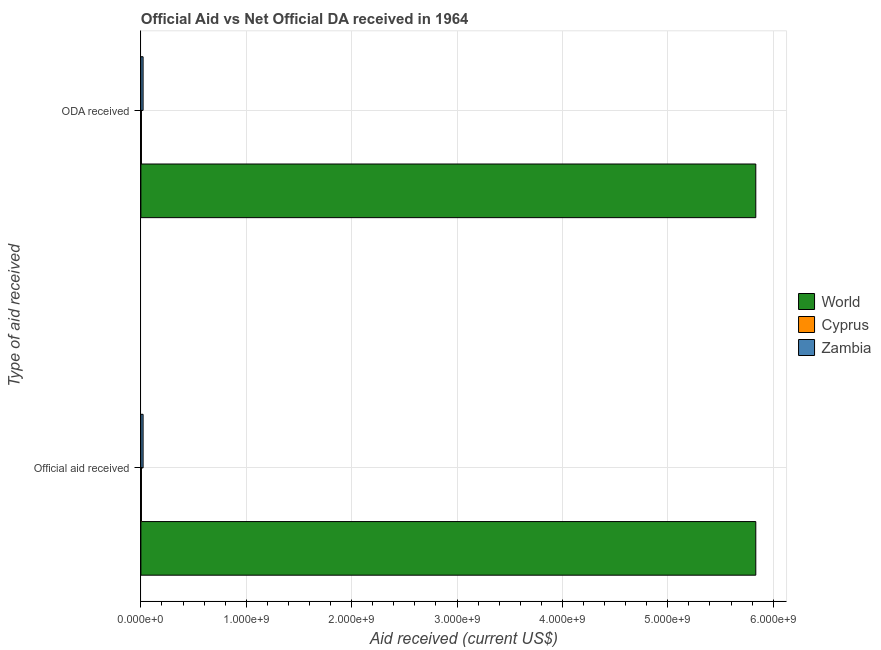How many different coloured bars are there?
Make the answer very short. 3. Are the number of bars per tick equal to the number of legend labels?
Keep it short and to the point. Yes. How many bars are there on the 1st tick from the top?
Your answer should be compact. 3. How many bars are there on the 1st tick from the bottom?
Provide a succinct answer. 3. What is the label of the 1st group of bars from the top?
Ensure brevity in your answer.  ODA received. What is the official aid received in Cyprus?
Keep it short and to the point. 5.24e+06. Across all countries, what is the maximum oda received?
Your answer should be very brief. 5.84e+09. Across all countries, what is the minimum official aid received?
Your response must be concise. 5.24e+06. In which country was the oda received maximum?
Ensure brevity in your answer.  World. In which country was the oda received minimum?
Offer a very short reply. Cyprus. What is the total oda received in the graph?
Offer a terse response. 5.86e+09. What is the difference between the oda received in Zambia and that in Cyprus?
Offer a very short reply. 1.58e+07. What is the difference between the official aid received in Zambia and the oda received in World?
Keep it short and to the point. -5.81e+09. What is the average oda received per country?
Your answer should be very brief. 1.95e+09. What is the difference between the official aid received and oda received in Cyprus?
Your response must be concise. 0. In how many countries, is the official aid received greater than 3800000000 US$?
Offer a very short reply. 1. What is the ratio of the official aid received in Cyprus to that in Zambia?
Offer a very short reply. 0.25. In how many countries, is the oda received greater than the average oda received taken over all countries?
Provide a short and direct response. 1. What does the 3rd bar from the top in ODA received represents?
Make the answer very short. World. What does the 3rd bar from the bottom in ODA received represents?
Offer a very short reply. Zambia. How many bars are there?
Your answer should be very brief. 6. Does the graph contain any zero values?
Give a very brief answer. No. Where does the legend appear in the graph?
Offer a terse response. Center right. How many legend labels are there?
Your answer should be compact. 3. How are the legend labels stacked?
Your response must be concise. Vertical. What is the title of the graph?
Make the answer very short. Official Aid vs Net Official DA received in 1964 . What is the label or title of the X-axis?
Offer a very short reply. Aid received (current US$). What is the label or title of the Y-axis?
Provide a succinct answer. Type of aid received. What is the Aid received (current US$) in World in Official aid received?
Make the answer very short. 5.84e+09. What is the Aid received (current US$) of Cyprus in Official aid received?
Ensure brevity in your answer.  5.24e+06. What is the Aid received (current US$) of Zambia in Official aid received?
Ensure brevity in your answer.  2.10e+07. What is the Aid received (current US$) in World in ODA received?
Provide a short and direct response. 5.84e+09. What is the Aid received (current US$) of Cyprus in ODA received?
Offer a very short reply. 5.24e+06. What is the Aid received (current US$) in Zambia in ODA received?
Offer a very short reply. 2.10e+07. Across all Type of aid received, what is the maximum Aid received (current US$) in World?
Your answer should be very brief. 5.84e+09. Across all Type of aid received, what is the maximum Aid received (current US$) of Cyprus?
Offer a terse response. 5.24e+06. Across all Type of aid received, what is the maximum Aid received (current US$) in Zambia?
Your answer should be compact. 2.10e+07. Across all Type of aid received, what is the minimum Aid received (current US$) of World?
Offer a very short reply. 5.84e+09. Across all Type of aid received, what is the minimum Aid received (current US$) in Cyprus?
Offer a very short reply. 5.24e+06. Across all Type of aid received, what is the minimum Aid received (current US$) of Zambia?
Ensure brevity in your answer.  2.10e+07. What is the total Aid received (current US$) of World in the graph?
Provide a short and direct response. 1.17e+1. What is the total Aid received (current US$) in Cyprus in the graph?
Provide a short and direct response. 1.05e+07. What is the total Aid received (current US$) of Zambia in the graph?
Ensure brevity in your answer.  4.20e+07. What is the difference between the Aid received (current US$) of World in Official aid received and that in ODA received?
Offer a very short reply. 0. What is the difference between the Aid received (current US$) of Zambia in Official aid received and that in ODA received?
Keep it short and to the point. 0. What is the difference between the Aid received (current US$) of World in Official aid received and the Aid received (current US$) of Cyprus in ODA received?
Your answer should be very brief. 5.83e+09. What is the difference between the Aid received (current US$) of World in Official aid received and the Aid received (current US$) of Zambia in ODA received?
Make the answer very short. 5.81e+09. What is the difference between the Aid received (current US$) of Cyprus in Official aid received and the Aid received (current US$) of Zambia in ODA received?
Offer a very short reply. -1.58e+07. What is the average Aid received (current US$) in World per Type of aid received?
Offer a very short reply. 5.84e+09. What is the average Aid received (current US$) of Cyprus per Type of aid received?
Provide a short and direct response. 5.24e+06. What is the average Aid received (current US$) in Zambia per Type of aid received?
Make the answer very short. 2.10e+07. What is the difference between the Aid received (current US$) in World and Aid received (current US$) in Cyprus in Official aid received?
Make the answer very short. 5.83e+09. What is the difference between the Aid received (current US$) in World and Aid received (current US$) in Zambia in Official aid received?
Your response must be concise. 5.81e+09. What is the difference between the Aid received (current US$) of Cyprus and Aid received (current US$) of Zambia in Official aid received?
Your answer should be very brief. -1.58e+07. What is the difference between the Aid received (current US$) in World and Aid received (current US$) in Cyprus in ODA received?
Your answer should be very brief. 5.83e+09. What is the difference between the Aid received (current US$) of World and Aid received (current US$) of Zambia in ODA received?
Your answer should be compact. 5.81e+09. What is the difference between the Aid received (current US$) of Cyprus and Aid received (current US$) of Zambia in ODA received?
Give a very brief answer. -1.58e+07. What is the ratio of the Aid received (current US$) of Cyprus in Official aid received to that in ODA received?
Your answer should be very brief. 1. What is the difference between the highest and the second highest Aid received (current US$) of World?
Your response must be concise. 0. What is the difference between the highest and the second highest Aid received (current US$) in Cyprus?
Ensure brevity in your answer.  0. 